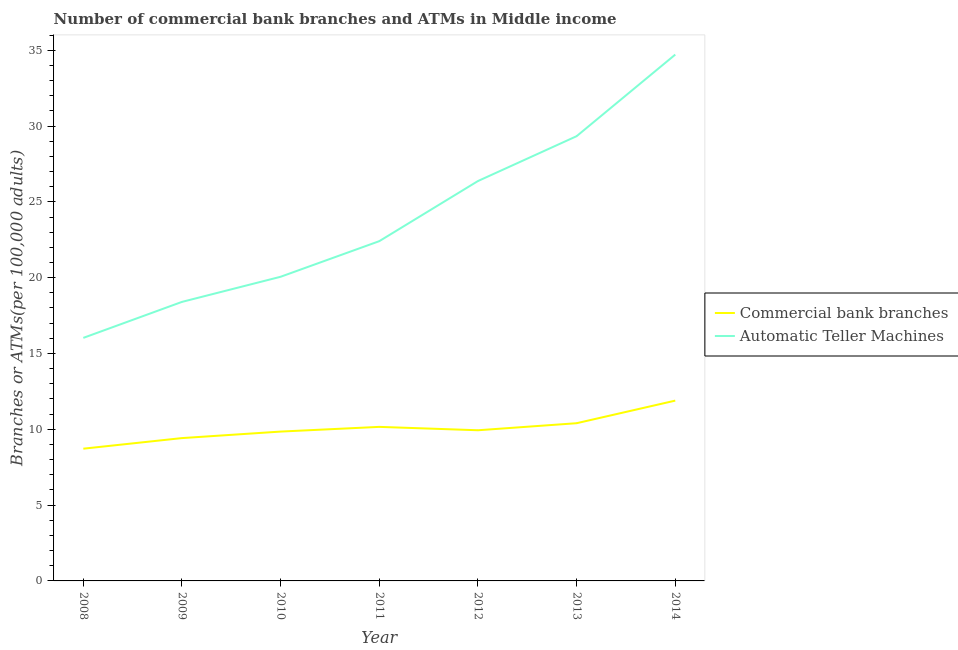Does the line corresponding to number of atms intersect with the line corresponding to number of commercal bank branches?
Your response must be concise. No. Is the number of lines equal to the number of legend labels?
Your answer should be compact. Yes. What is the number of commercal bank branches in 2012?
Provide a succinct answer. 9.94. Across all years, what is the maximum number of commercal bank branches?
Offer a terse response. 11.89. Across all years, what is the minimum number of atms?
Offer a very short reply. 16.03. In which year was the number of commercal bank branches maximum?
Make the answer very short. 2014. In which year was the number of commercal bank branches minimum?
Make the answer very short. 2008. What is the total number of commercal bank branches in the graph?
Provide a succinct answer. 70.38. What is the difference between the number of atms in 2013 and that in 2014?
Offer a very short reply. -5.38. What is the difference between the number of commercal bank branches in 2009 and the number of atms in 2014?
Offer a very short reply. -25.29. What is the average number of commercal bank branches per year?
Offer a terse response. 10.05. In the year 2009, what is the difference between the number of commercal bank branches and number of atms?
Keep it short and to the point. -8.98. What is the ratio of the number of atms in 2011 to that in 2014?
Your answer should be compact. 0.65. Is the number of atms in 2008 less than that in 2012?
Your response must be concise. Yes. Is the difference between the number of commercal bank branches in 2012 and 2013 greater than the difference between the number of atms in 2012 and 2013?
Give a very brief answer. Yes. What is the difference between the highest and the second highest number of commercal bank branches?
Make the answer very short. 1.49. What is the difference between the highest and the lowest number of atms?
Your response must be concise. 18.68. Is the sum of the number of commercal bank branches in 2011 and 2012 greater than the maximum number of atms across all years?
Ensure brevity in your answer.  No. Does the number of atms monotonically increase over the years?
Provide a succinct answer. Yes. Is the number of atms strictly greater than the number of commercal bank branches over the years?
Your answer should be compact. Yes. What is the difference between two consecutive major ticks on the Y-axis?
Your answer should be very brief. 5. Does the graph contain any zero values?
Your answer should be very brief. No. Does the graph contain grids?
Give a very brief answer. No. Where does the legend appear in the graph?
Your answer should be very brief. Center right. What is the title of the graph?
Provide a succinct answer. Number of commercial bank branches and ATMs in Middle income. Does "Lowest 10% of population" appear as one of the legend labels in the graph?
Make the answer very short. No. What is the label or title of the X-axis?
Provide a short and direct response. Year. What is the label or title of the Y-axis?
Provide a succinct answer. Branches or ATMs(per 100,0 adults). What is the Branches or ATMs(per 100,000 adults) in Commercial bank branches in 2008?
Your answer should be very brief. 8.72. What is the Branches or ATMs(per 100,000 adults) in Automatic Teller Machines in 2008?
Keep it short and to the point. 16.03. What is the Branches or ATMs(per 100,000 adults) in Commercial bank branches in 2009?
Your response must be concise. 9.42. What is the Branches or ATMs(per 100,000 adults) in Automatic Teller Machines in 2009?
Offer a very short reply. 18.4. What is the Branches or ATMs(per 100,000 adults) in Commercial bank branches in 2010?
Provide a succinct answer. 9.85. What is the Branches or ATMs(per 100,000 adults) of Automatic Teller Machines in 2010?
Make the answer very short. 20.06. What is the Branches or ATMs(per 100,000 adults) of Commercial bank branches in 2011?
Give a very brief answer. 10.16. What is the Branches or ATMs(per 100,000 adults) in Automatic Teller Machines in 2011?
Keep it short and to the point. 22.41. What is the Branches or ATMs(per 100,000 adults) of Commercial bank branches in 2012?
Your answer should be compact. 9.94. What is the Branches or ATMs(per 100,000 adults) in Automatic Teller Machines in 2012?
Offer a very short reply. 26.37. What is the Branches or ATMs(per 100,000 adults) in Commercial bank branches in 2013?
Keep it short and to the point. 10.4. What is the Branches or ATMs(per 100,000 adults) in Automatic Teller Machines in 2013?
Provide a short and direct response. 29.33. What is the Branches or ATMs(per 100,000 adults) of Commercial bank branches in 2014?
Give a very brief answer. 11.89. What is the Branches or ATMs(per 100,000 adults) in Automatic Teller Machines in 2014?
Ensure brevity in your answer.  34.71. Across all years, what is the maximum Branches or ATMs(per 100,000 adults) of Commercial bank branches?
Give a very brief answer. 11.89. Across all years, what is the maximum Branches or ATMs(per 100,000 adults) in Automatic Teller Machines?
Provide a succinct answer. 34.71. Across all years, what is the minimum Branches or ATMs(per 100,000 adults) of Commercial bank branches?
Your response must be concise. 8.72. Across all years, what is the minimum Branches or ATMs(per 100,000 adults) of Automatic Teller Machines?
Provide a succinct answer. 16.03. What is the total Branches or ATMs(per 100,000 adults) in Commercial bank branches in the graph?
Keep it short and to the point. 70.38. What is the total Branches or ATMs(per 100,000 adults) in Automatic Teller Machines in the graph?
Provide a short and direct response. 167.31. What is the difference between the Branches or ATMs(per 100,000 adults) of Commercial bank branches in 2008 and that in 2009?
Provide a short and direct response. -0.7. What is the difference between the Branches or ATMs(per 100,000 adults) in Automatic Teller Machines in 2008 and that in 2009?
Your answer should be compact. -2.37. What is the difference between the Branches or ATMs(per 100,000 adults) of Commercial bank branches in 2008 and that in 2010?
Provide a succinct answer. -1.13. What is the difference between the Branches or ATMs(per 100,000 adults) in Automatic Teller Machines in 2008 and that in 2010?
Keep it short and to the point. -4.03. What is the difference between the Branches or ATMs(per 100,000 adults) of Commercial bank branches in 2008 and that in 2011?
Provide a succinct answer. -1.44. What is the difference between the Branches or ATMs(per 100,000 adults) of Automatic Teller Machines in 2008 and that in 2011?
Keep it short and to the point. -6.38. What is the difference between the Branches or ATMs(per 100,000 adults) in Commercial bank branches in 2008 and that in 2012?
Ensure brevity in your answer.  -1.21. What is the difference between the Branches or ATMs(per 100,000 adults) of Automatic Teller Machines in 2008 and that in 2012?
Provide a succinct answer. -10.34. What is the difference between the Branches or ATMs(per 100,000 adults) in Commercial bank branches in 2008 and that in 2013?
Offer a very short reply. -1.68. What is the difference between the Branches or ATMs(per 100,000 adults) of Automatic Teller Machines in 2008 and that in 2013?
Offer a very short reply. -13.3. What is the difference between the Branches or ATMs(per 100,000 adults) of Commercial bank branches in 2008 and that in 2014?
Keep it short and to the point. -3.17. What is the difference between the Branches or ATMs(per 100,000 adults) of Automatic Teller Machines in 2008 and that in 2014?
Keep it short and to the point. -18.68. What is the difference between the Branches or ATMs(per 100,000 adults) of Commercial bank branches in 2009 and that in 2010?
Make the answer very short. -0.43. What is the difference between the Branches or ATMs(per 100,000 adults) of Automatic Teller Machines in 2009 and that in 2010?
Keep it short and to the point. -1.66. What is the difference between the Branches or ATMs(per 100,000 adults) in Commercial bank branches in 2009 and that in 2011?
Your answer should be very brief. -0.74. What is the difference between the Branches or ATMs(per 100,000 adults) of Automatic Teller Machines in 2009 and that in 2011?
Offer a terse response. -4.01. What is the difference between the Branches or ATMs(per 100,000 adults) of Commercial bank branches in 2009 and that in 2012?
Your answer should be very brief. -0.52. What is the difference between the Branches or ATMs(per 100,000 adults) in Automatic Teller Machines in 2009 and that in 2012?
Keep it short and to the point. -7.97. What is the difference between the Branches or ATMs(per 100,000 adults) in Commercial bank branches in 2009 and that in 2013?
Make the answer very short. -0.98. What is the difference between the Branches or ATMs(per 100,000 adults) of Automatic Teller Machines in 2009 and that in 2013?
Your answer should be very brief. -10.93. What is the difference between the Branches or ATMs(per 100,000 adults) of Commercial bank branches in 2009 and that in 2014?
Your answer should be very brief. -2.47. What is the difference between the Branches or ATMs(per 100,000 adults) of Automatic Teller Machines in 2009 and that in 2014?
Your answer should be very brief. -16.31. What is the difference between the Branches or ATMs(per 100,000 adults) of Commercial bank branches in 2010 and that in 2011?
Provide a short and direct response. -0.31. What is the difference between the Branches or ATMs(per 100,000 adults) of Automatic Teller Machines in 2010 and that in 2011?
Give a very brief answer. -2.35. What is the difference between the Branches or ATMs(per 100,000 adults) in Commercial bank branches in 2010 and that in 2012?
Your answer should be very brief. -0.09. What is the difference between the Branches or ATMs(per 100,000 adults) in Automatic Teller Machines in 2010 and that in 2012?
Provide a short and direct response. -6.31. What is the difference between the Branches or ATMs(per 100,000 adults) of Commercial bank branches in 2010 and that in 2013?
Your answer should be compact. -0.55. What is the difference between the Branches or ATMs(per 100,000 adults) in Automatic Teller Machines in 2010 and that in 2013?
Provide a short and direct response. -9.27. What is the difference between the Branches or ATMs(per 100,000 adults) of Commercial bank branches in 2010 and that in 2014?
Keep it short and to the point. -2.04. What is the difference between the Branches or ATMs(per 100,000 adults) of Automatic Teller Machines in 2010 and that in 2014?
Provide a short and direct response. -14.65. What is the difference between the Branches or ATMs(per 100,000 adults) in Commercial bank branches in 2011 and that in 2012?
Provide a succinct answer. 0.22. What is the difference between the Branches or ATMs(per 100,000 adults) in Automatic Teller Machines in 2011 and that in 2012?
Make the answer very short. -3.96. What is the difference between the Branches or ATMs(per 100,000 adults) in Commercial bank branches in 2011 and that in 2013?
Give a very brief answer. -0.24. What is the difference between the Branches or ATMs(per 100,000 adults) of Automatic Teller Machines in 2011 and that in 2013?
Make the answer very short. -6.92. What is the difference between the Branches or ATMs(per 100,000 adults) of Commercial bank branches in 2011 and that in 2014?
Make the answer very short. -1.73. What is the difference between the Branches or ATMs(per 100,000 adults) in Automatic Teller Machines in 2011 and that in 2014?
Give a very brief answer. -12.3. What is the difference between the Branches or ATMs(per 100,000 adults) of Commercial bank branches in 2012 and that in 2013?
Your answer should be very brief. -0.46. What is the difference between the Branches or ATMs(per 100,000 adults) in Automatic Teller Machines in 2012 and that in 2013?
Your answer should be very brief. -2.96. What is the difference between the Branches or ATMs(per 100,000 adults) in Commercial bank branches in 2012 and that in 2014?
Make the answer very short. -1.95. What is the difference between the Branches or ATMs(per 100,000 adults) in Automatic Teller Machines in 2012 and that in 2014?
Offer a very short reply. -8.34. What is the difference between the Branches or ATMs(per 100,000 adults) of Commercial bank branches in 2013 and that in 2014?
Provide a short and direct response. -1.49. What is the difference between the Branches or ATMs(per 100,000 adults) of Automatic Teller Machines in 2013 and that in 2014?
Your response must be concise. -5.38. What is the difference between the Branches or ATMs(per 100,000 adults) of Commercial bank branches in 2008 and the Branches or ATMs(per 100,000 adults) of Automatic Teller Machines in 2009?
Provide a short and direct response. -9.68. What is the difference between the Branches or ATMs(per 100,000 adults) of Commercial bank branches in 2008 and the Branches or ATMs(per 100,000 adults) of Automatic Teller Machines in 2010?
Your answer should be compact. -11.34. What is the difference between the Branches or ATMs(per 100,000 adults) in Commercial bank branches in 2008 and the Branches or ATMs(per 100,000 adults) in Automatic Teller Machines in 2011?
Make the answer very short. -13.69. What is the difference between the Branches or ATMs(per 100,000 adults) in Commercial bank branches in 2008 and the Branches or ATMs(per 100,000 adults) in Automatic Teller Machines in 2012?
Make the answer very short. -17.65. What is the difference between the Branches or ATMs(per 100,000 adults) in Commercial bank branches in 2008 and the Branches or ATMs(per 100,000 adults) in Automatic Teller Machines in 2013?
Provide a succinct answer. -20.61. What is the difference between the Branches or ATMs(per 100,000 adults) in Commercial bank branches in 2008 and the Branches or ATMs(per 100,000 adults) in Automatic Teller Machines in 2014?
Ensure brevity in your answer.  -25.99. What is the difference between the Branches or ATMs(per 100,000 adults) in Commercial bank branches in 2009 and the Branches or ATMs(per 100,000 adults) in Automatic Teller Machines in 2010?
Offer a very short reply. -10.64. What is the difference between the Branches or ATMs(per 100,000 adults) of Commercial bank branches in 2009 and the Branches or ATMs(per 100,000 adults) of Automatic Teller Machines in 2011?
Provide a short and direct response. -12.99. What is the difference between the Branches or ATMs(per 100,000 adults) of Commercial bank branches in 2009 and the Branches or ATMs(per 100,000 adults) of Automatic Teller Machines in 2012?
Keep it short and to the point. -16.95. What is the difference between the Branches or ATMs(per 100,000 adults) of Commercial bank branches in 2009 and the Branches or ATMs(per 100,000 adults) of Automatic Teller Machines in 2013?
Your answer should be very brief. -19.91. What is the difference between the Branches or ATMs(per 100,000 adults) in Commercial bank branches in 2009 and the Branches or ATMs(per 100,000 adults) in Automatic Teller Machines in 2014?
Offer a terse response. -25.29. What is the difference between the Branches or ATMs(per 100,000 adults) in Commercial bank branches in 2010 and the Branches or ATMs(per 100,000 adults) in Automatic Teller Machines in 2011?
Give a very brief answer. -12.56. What is the difference between the Branches or ATMs(per 100,000 adults) of Commercial bank branches in 2010 and the Branches or ATMs(per 100,000 adults) of Automatic Teller Machines in 2012?
Offer a terse response. -16.52. What is the difference between the Branches or ATMs(per 100,000 adults) of Commercial bank branches in 2010 and the Branches or ATMs(per 100,000 adults) of Automatic Teller Machines in 2013?
Make the answer very short. -19.48. What is the difference between the Branches or ATMs(per 100,000 adults) in Commercial bank branches in 2010 and the Branches or ATMs(per 100,000 adults) in Automatic Teller Machines in 2014?
Provide a short and direct response. -24.86. What is the difference between the Branches or ATMs(per 100,000 adults) of Commercial bank branches in 2011 and the Branches or ATMs(per 100,000 adults) of Automatic Teller Machines in 2012?
Ensure brevity in your answer.  -16.21. What is the difference between the Branches or ATMs(per 100,000 adults) in Commercial bank branches in 2011 and the Branches or ATMs(per 100,000 adults) in Automatic Teller Machines in 2013?
Offer a terse response. -19.17. What is the difference between the Branches or ATMs(per 100,000 adults) in Commercial bank branches in 2011 and the Branches or ATMs(per 100,000 adults) in Automatic Teller Machines in 2014?
Your answer should be very brief. -24.55. What is the difference between the Branches or ATMs(per 100,000 adults) of Commercial bank branches in 2012 and the Branches or ATMs(per 100,000 adults) of Automatic Teller Machines in 2013?
Offer a very short reply. -19.39. What is the difference between the Branches or ATMs(per 100,000 adults) of Commercial bank branches in 2012 and the Branches or ATMs(per 100,000 adults) of Automatic Teller Machines in 2014?
Your response must be concise. -24.78. What is the difference between the Branches or ATMs(per 100,000 adults) in Commercial bank branches in 2013 and the Branches or ATMs(per 100,000 adults) in Automatic Teller Machines in 2014?
Provide a short and direct response. -24.31. What is the average Branches or ATMs(per 100,000 adults) of Commercial bank branches per year?
Provide a succinct answer. 10.05. What is the average Branches or ATMs(per 100,000 adults) in Automatic Teller Machines per year?
Your response must be concise. 23.9. In the year 2008, what is the difference between the Branches or ATMs(per 100,000 adults) in Commercial bank branches and Branches or ATMs(per 100,000 adults) in Automatic Teller Machines?
Ensure brevity in your answer.  -7.31. In the year 2009, what is the difference between the Branches or ATMs(per 100,000 adults) of Commercial bank branches and Branches or ATMs(per 100,000 adults) of Automatic Teller Machines?
Your response must be concise. -8.98. In the year 2010, what is the difference between the Branches or ATMs(per 100,000 adults) in Commercial bank branches and Branches or ATMs(per 100,000 adults) in Automatic Teller Machines?
Your response must be concise. -10.21. In the year 2011, what is the difference between the Branches or ATMs(per 100,000 adults) of Commercial bank branches and Branches or ATMs(per 100,000 adults) of Automatic Teller Machines?
Ensure brevity in your answer.  -12.25. In the year 2012, what is the difference between the Branches or ATMs(per 100,000 adults) in Commercial bank branches and Branches or ATMs(per 100,000 adults) in Automatic Teller Machines?
Make the answer very short. -16.44. In the year 2013, what is the difference between the Branches or ATMs(per 100,000 adults) in Commercial bank branches and Branches or ATMs(per 100,000 adults) in Automatic Teller Machines?
Offer a terse response. -18.93. In the year 2014, what is the difference between the Branches or ATMs(per 100,000 adults) in Commercial bank branches and Branches or ATMs(per 100,000 adults) in Automatic Teller Machines?
Provide a succinct answer. -22.82. What is the ratio of the Branches or ATMs(per 100,000 adults) in Commercial bank branches in 2008 to that in 2009?
Provide a succinct answer. 0.93. What is the ratio of the Branches or ATMs(per 100,000 adults) of Automatic Teller Machines in 2008 to that in 2009?
Give a very brief answer. 0.87. What is the ratio of the Branches or ATMs(per 100,000 adults) of Commercial bank branches in 2008 to that in 2010?
Make the answer very short. 0.89. What is the ratio of the Branches or ATMs(per 100,000 adults) in Automatic Teller Machines in 2008 to that in 2010?
Your answer should be compact. 0.8. What is the ratio of the Branches or ATMs(per 100,000 adults) in Commercial bank branches in 2008 to that in 2011?
Provide a short and direct response. 0.86. What is the ratio of the Branches or ATMs(per 100,000 adults) in Automatic Teller Machines in 2008 to that in 2011?
Provide a short and direct response. 0.72. What is the ratio of the Branches or ATMs(per 100,000 adults) in Commercial bank branches in 2008 to that in 2012?
Offer a terse response. 0.88. What is the ratio of the Branches or ATMs(per 100,000 adults) in Automatic Teller Machines in 2008 to that in 2012?
Offer a very short reply. 0.61. What is the ratio of the Branches or ATMs(per 100,000 adults) in Commercial bank branches in 2008 to that in 2013?
Provide a short and direct response. 0.84. What is the ratio of the Branches or ATMs(per 100,000 adults) of Automatic Teller Machines in 2008 to that in 2013?
Provide a succinct answer. 0.55. What is the ratio of the Branches or ATMs(per 100,000 adults) in Commercial bank branches in 2008 to that in 2014?
Make the answer very short. 0.73. What is the ratio of the Branches or ATMs(per 100,000 adults) in Automatic Teller Machines in 2008 to that in 2014?
Give a very brief answer. 0.46. What is the ratio of the Branches or ATMs(per 100,000 adults) in Commercial bank branches in 2009 to that in 2010?
Keep it short and to the point. 0.96. What is the ratio of the Branches or ATMs(per 100,000 adults) in Automatic Teller Machines in 2009 to that in 2010?
Provide a succinct answer. 0.92. What is the ratio of the Branches or ATMs(per 100,000 adults) in Commercial bank branches in 2009 to that in 2011?
Offer a very short reply. 0.93. What is the ratio of the Branches or ATMs(per 100,000 adults) in Automatic Teller Machines in 2009 to that in 2011?
Ensure brevity in your answer.  0.82. What is the ratio of the Branches or ATMs(per 100,000 adults) in Commercial bank branches in 2009 to that in 2012?
Offer a very short reply. 0.95. What is the ratio of the Branches or ATMs(per 100,000 adults) in Automatic Teller Machines in 2009 to that in 2012?
Make the answer very short. 0.7. What is the ratio of the Branches or ATMs(per 100,000 adults) of Commercial bank branches in 2009 to that in 2013?
Offer a terse response. 0.91. What is the ratio of the Branches or ATMs(per 100,000 adults) of Automatic Teller Machines in 2009 to that in 2013?
Offer a very short reply. 0.63. What is the ratio of the Branches or ATMs(per 100,000 adults) of Commercial bank branches in 2009 to that in 2014?
Your answer should be very brief. 0.79. What is the ratio of the Branches or ATMs(per 100,000 adults) in Automatic Teller Machines in 2009 to that in 2014?
Keep it short and to the point. 0.53. What is the ratio of the Branches or ATMs(per 100,000 adults) in Commercial bank branches in 2010 to that in 2011?
Provide a short and direct response. 0.97. What is the ratio of the Branches or ATMs(per 100,000 adults) in Automatic Teller Machines in 2010 to that in 2011?
Make the answer very short. 0.9. What is the ratio of the Branches or ATMs(per 100,000 adults) in Commercial bank branches in 2010 to that in 2012?
Make the answer very short. 0.99. What is the ratio of the Branches or ATMs(per 100,000 adults) in Automatic Teller Machines in 2010 to that in 2012?
Ensure brevity in your answer.  0.76. What is the ratio of the Branches or ATMs(per 100,000 adults) of Commercial bank branches in 2010 to that in 2013?
Your answer should be compact. 0.95. What is the ratio of the Branches or ATMs(per 100,000 adults) in Automatic Teller Machines in 2010 to that in 2013?
Offer a very short reply. 0.68. What is the ratio of the Branches or ATMs(per 100,000 adults) in Commercial bank branches in 2010 to that in 2014?
Keep it short and to the point. 0.83. What is the ratio of the Branches or ATMs(per 100,000 adults) of Automatic Teller Machines in 2010 to that in 2014?
Your response must be concise. 0.58. What is the ratio of the Branches or ATMs(per 100,000 adults) of Commercial bank branches in 2011 to that in 2012?
Offer a very short reply. 1.02. What is the ratio of the Branches or ATMs(per 100,000 adults) in Automatic Teller Machines in 2011 to that in 2012?
Offer a terse response. 0.85. What is the ratio of the Branches or ATMs(per 100,000 adults) in Commercial bank branches in 2011 to that in 2013?
Offer a very short reply. 0.98. What is the ratio of the Branches or ATMs(per 100,000 adults) of Automatic Teller Machines in 2011 to that in 2013?
Ensure brevity in your answer.  0.76. What is the ratio of the Branches or ATMs(per 100,000 adults) of Commercial bank branches in 2011 to that in 2014?
Offer a terse response. 0.85. What is the ratio of the Branches or ATMs(per 100,000 adults) in Automatic Teller Machines in 2011 to that in 2014?
Your response must be concise. 0.65. What is the ratio of the Branches or ATMs(per 100,000 adults) in Commercial bank branches in 2012 to that in 2013?
Give a very brief answer. 0.96. What is the ratio of the Branches or ATMs(per 100,000 adults) of Automatic Teller Machines in 2012 to that in 2013?
Provide a succinct answer. 0.9. What is the ratio of the Branches or ATMs(per 100,000 adults) in Commercial bank branches in 2012 to that in 2014?
Offer a terse response. 0.84. What is the ratio of the Branches or ATMs(per 100,000 adults) in Automatic Teller Machines in 2012 to that in 2014?
Keep it short and to the point. 0.76. What is the ratio of the Branches or ATMs(per 100,000 adults) of Commercial bank branches in 2013 to that in 2014?
Ensure brevity in your answer.  0.87. What is the ratio of the Branches or ATMs(per 100,000 adults) of Automatic Teller Machines in 2013 to that in 2014?
Give a very brief answer. 0.84. What is the difference between the highest and the second highest Branches or ATMs(per 100,000 adults) in Commercial bank branches?
Offer a terse response. 1.49. What is the difference between the highest and the second highest Branches or ATMs(per 100,000 adults) of Automatic Teller Machines?
Keep it short and to the point. 5.38. What is the difference between the highest and the lowest Branches or ATMs(per 100,000 adults) of Commercial bank branches?
Provide a short and direct response. 3.17. What is the difference between the highest and the lowest Branches or ATMs(per 100,000 adults) of Automatic Teller Machines?
Make the answer very short. 18.68. 